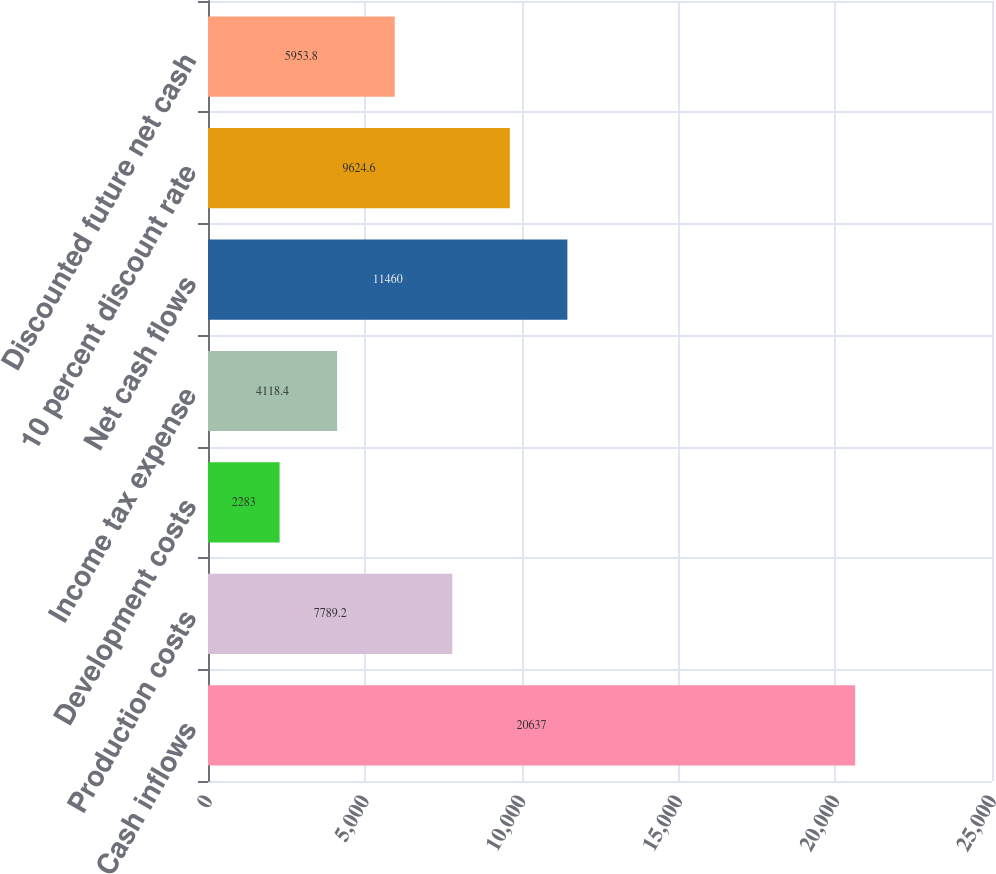Convert chart to OTSL. <chart><loc_0><loc_0><loc_500><loc_500><bar_chart><fcel>Cash inflows<fcel>Production costs<fcel>Development costs<fcel>Income tax expense<fcel>Net cash flows<fcel>10 percent discount rate<fcel>Discounted future net cash<nl><fcel>20637<fcel>7789.2<fcel>2283<fcel>4118.4<fcel>11460<fcel>9624.6<fcel>5953.8<nl></chart> 